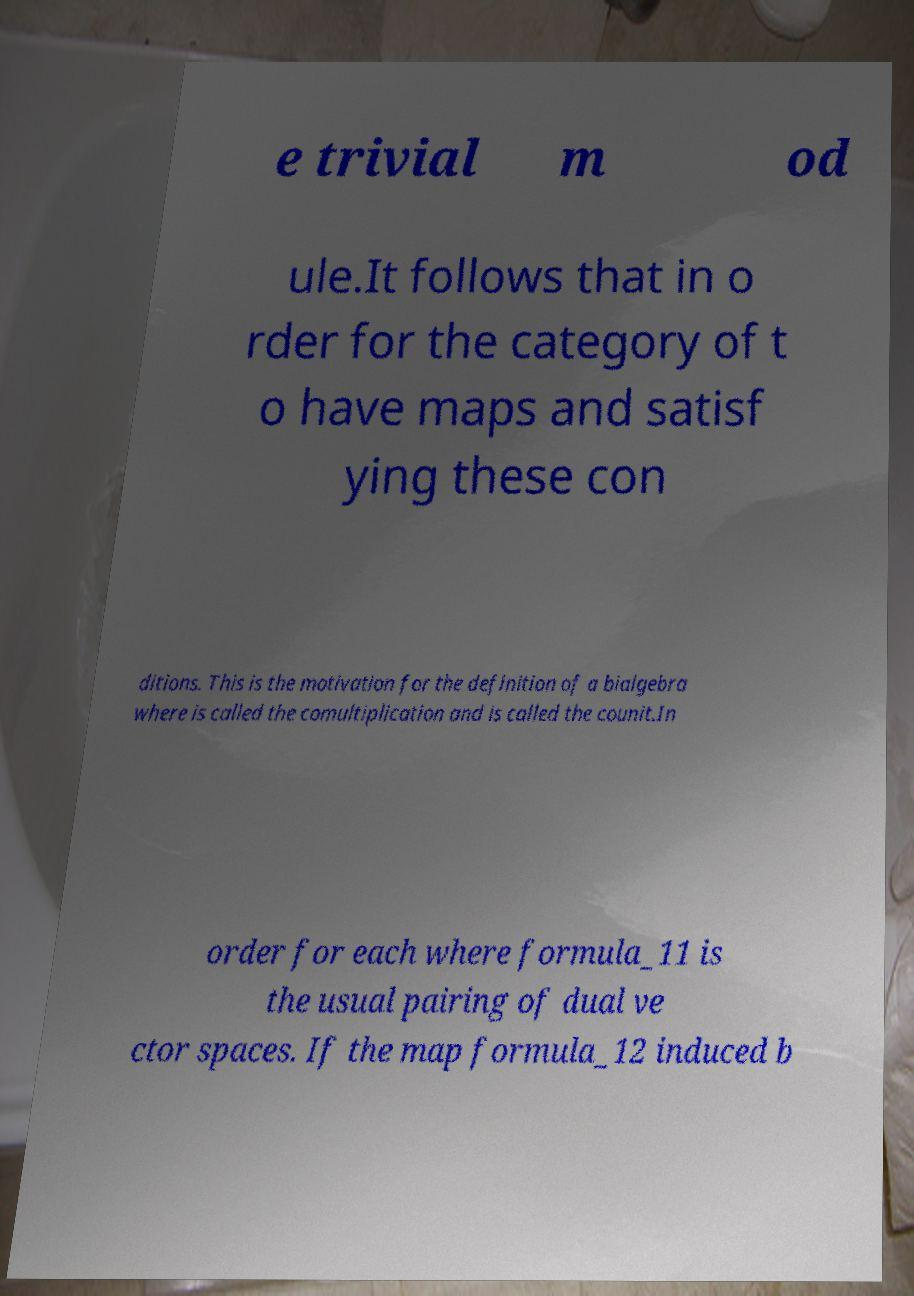Can you accurately transcribe the text from the provided image for me? e trivial m od ule.It follows that in o rder for the category of t o have maps and satisf ying these con ditions. This is the motivation for the definition of a bialgebra where is called the comultiplication and is called the counit.In order for each where formula_11 is the usual pairing of dual ve ctor spaces. If the map formula_12 induced b 